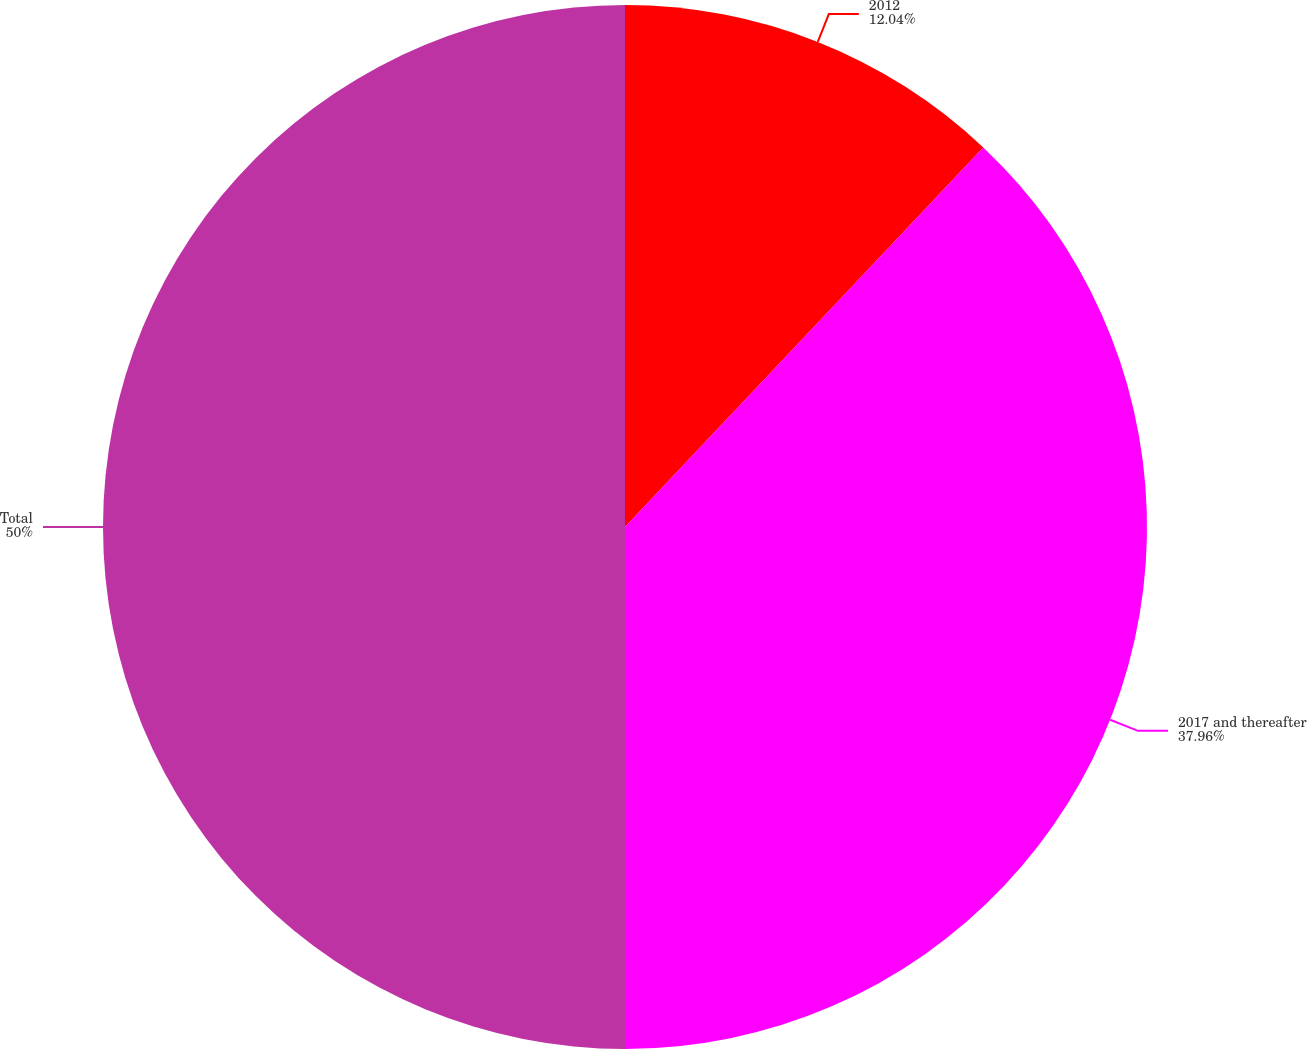Convert chart. <chart><loc_0><loc_0><loc_500><loc_500><pie_chart><fcel>2012<fcel>2017 and thereafter<fcel>Total<nl><fcel>12.04%<fcel>37.96%<fcel>50.0%<nl></chart> 